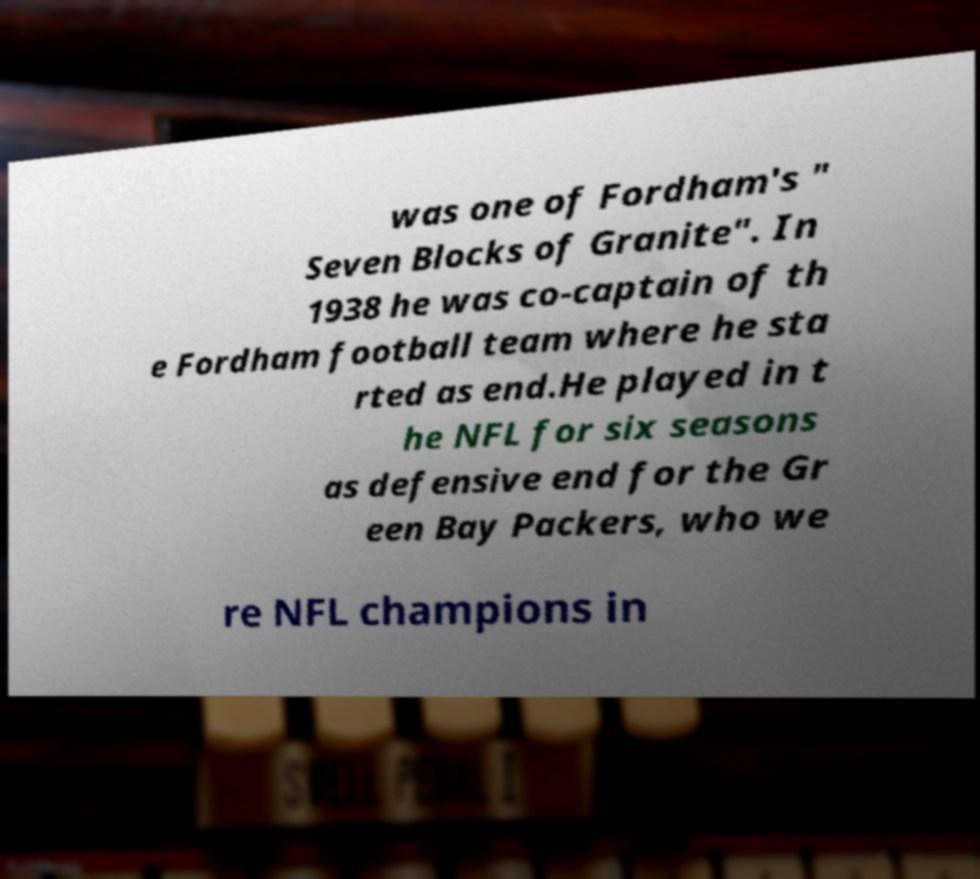What messages or text are displayed in this image? I need them in a readable, typed format. was one of Fordham's " Seven Blocks of Granite". In 1938 he was co-captain of th e Fordham football team where he sta rted as end.He played in t he NFL for six seasons as defensive end for the Gr een Bay Packers, who we re NFL champions in 